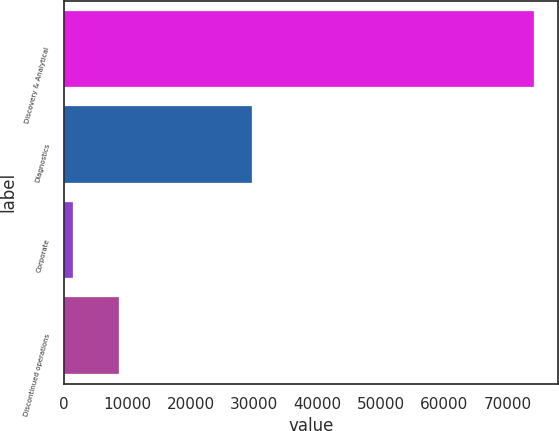Convert chart. <chart><loc_0><loc_0><loc_500><loc_500><bar_chart><fcel>Discovery & Analytical<fcel>Diagnostics<fcel>Corporate<fcel>Discontinued operations<nl><fcel>74177<fcel>29728<fcel>1459<fcel>8730.8<nl></chart> 